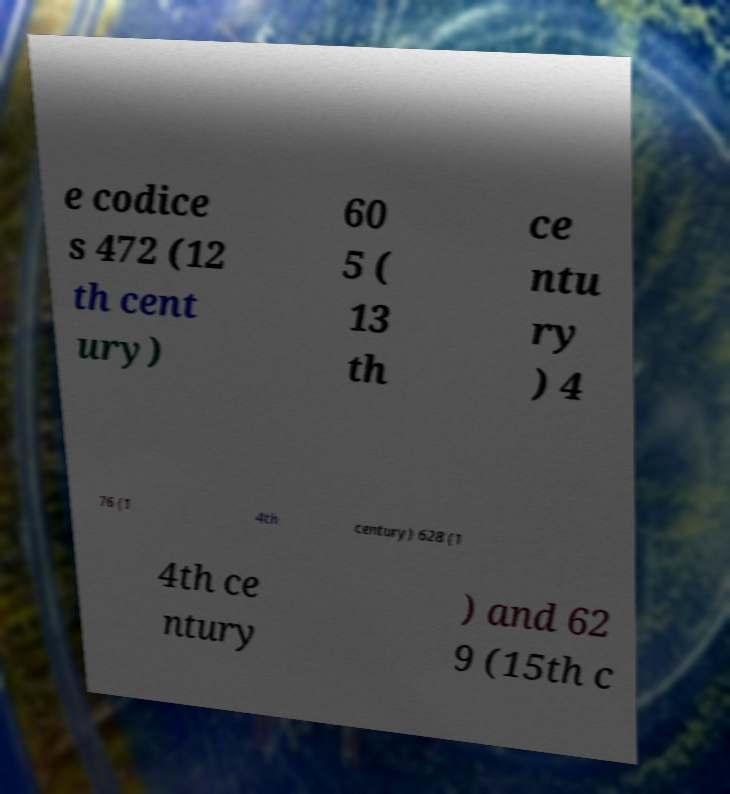Can you read and provide the text displayed in the image?This photo seems to have some interesting text. Can you extract and type it out for me? e codice s 472 (12 th cent ury) 60 5 ( 13 th ce ntu ry ) 4 76 (1 4th century) 628 (1 4th ce ntury ) and 62 9 (15th c 